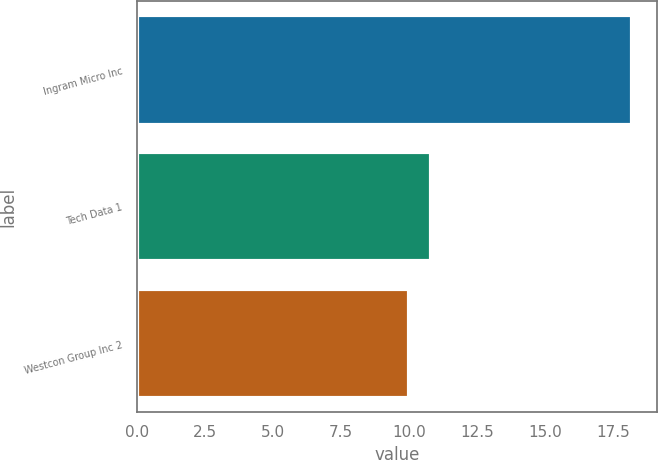Convert chart to OTSL. <chart><loc_0><loc_0><loc_500><loc_500><bar_chart><fcel>Ingram Micro Inc<fcel>Tech Data 1<fcel>Westcon Group Inc 2<nl><fcel>18.2<fcel>10.82<fcel>10<nl></chart> 